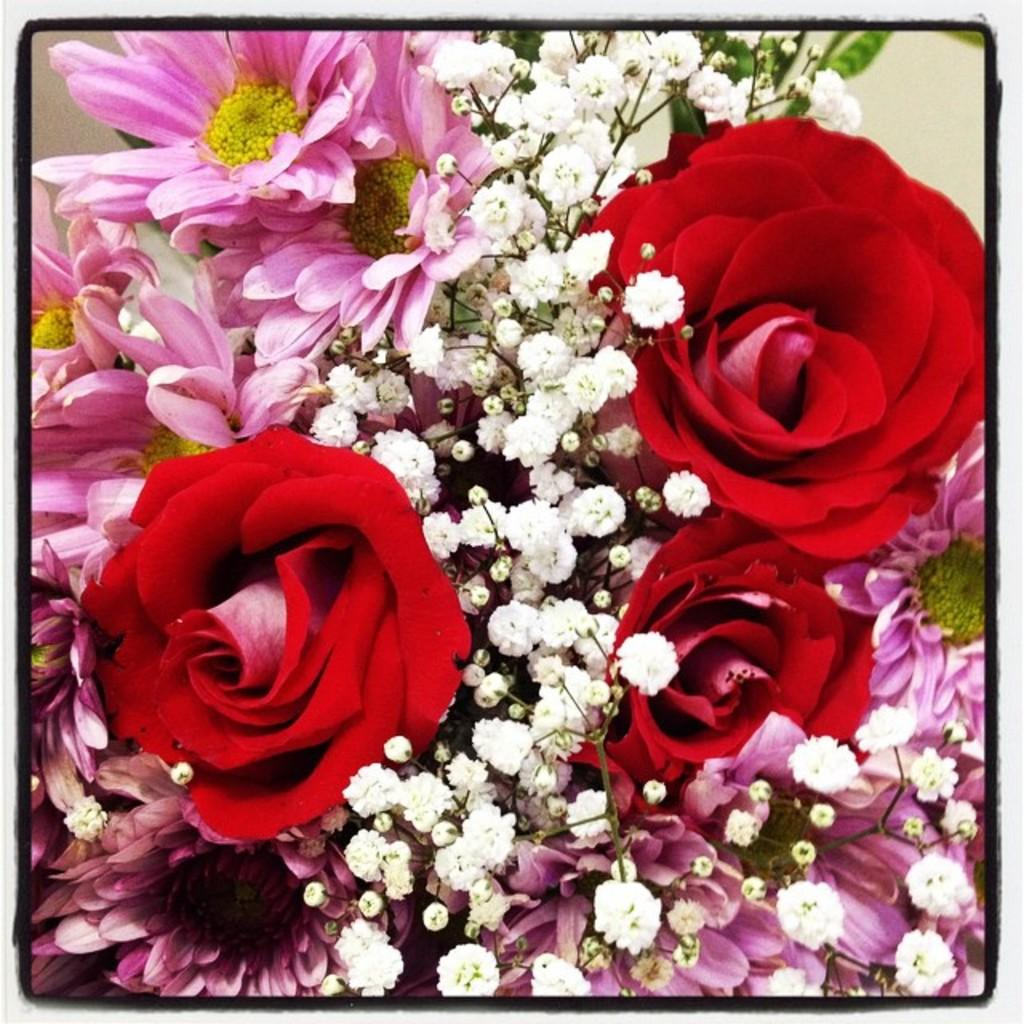What type of plants can be seen in the image? There are flowering plants in the image. Can you describe the stage of growth for some of the plants? Yes, there are buds in the image. What is the background of the image? There is a wall in the image. How is the image presented? The image appears to be a photo frame. What type of scent can be detected from the girl in the image? There is no girl present in the image, so it is not possible to detect any scent from her. 